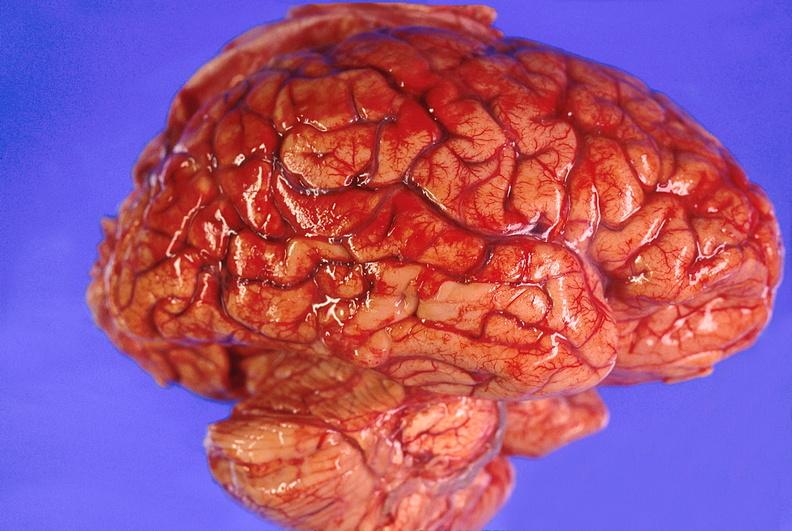s chromophobe adenoma present?
Answer the question using a single word or phrase. No 